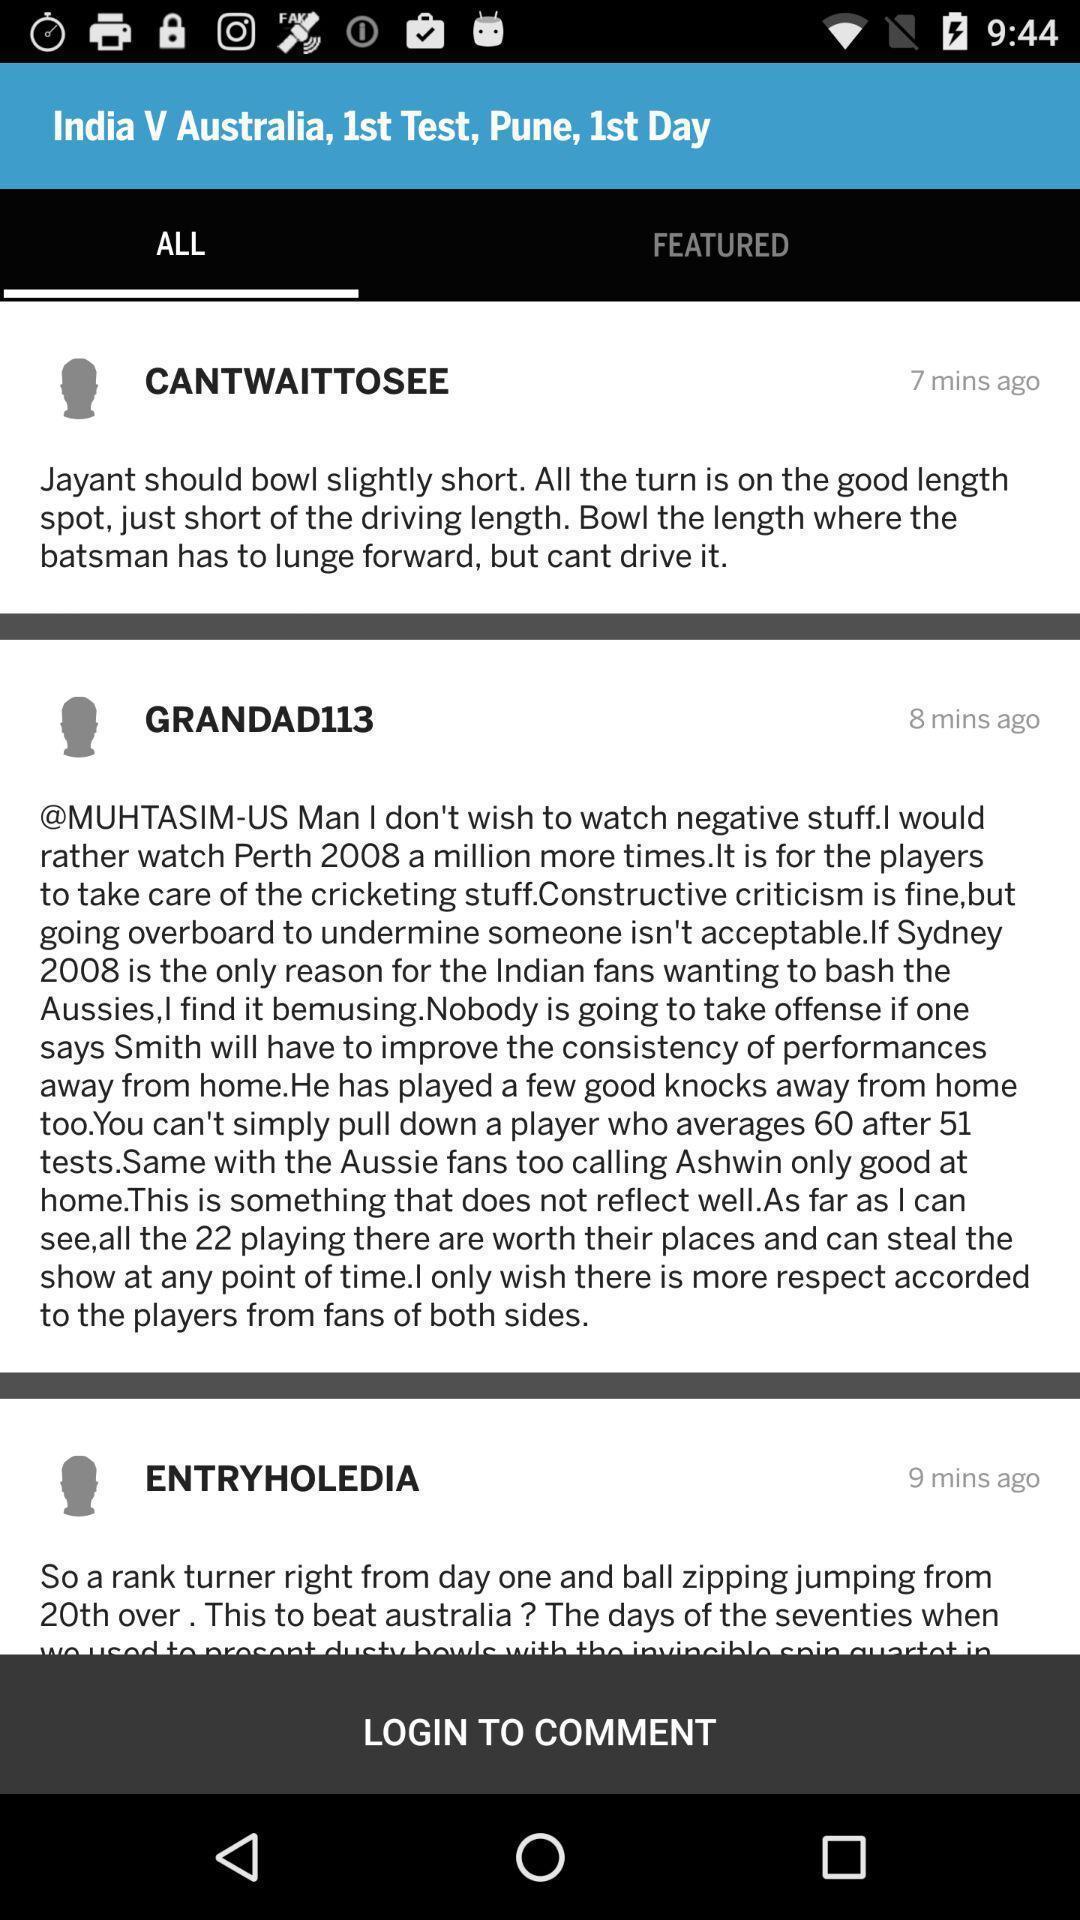Tell me about the visual elements in this screen capture. Screen shows several comments on a application. 